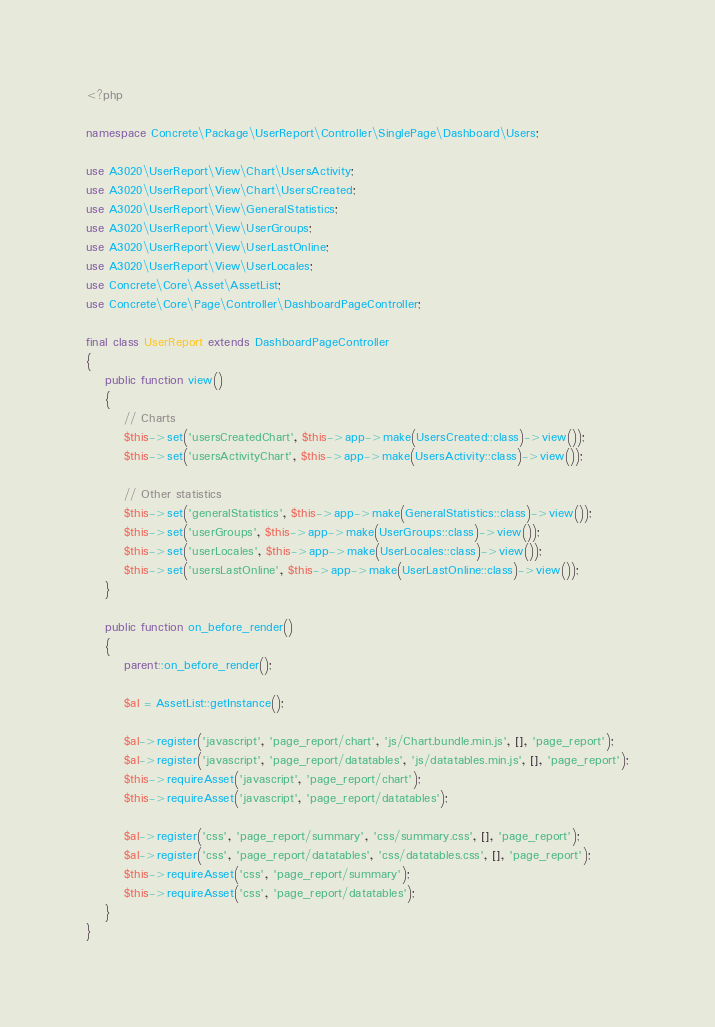Convert code to text. <code><loc_0><loc_0><loc_500><loc_500><_PHP_><?php

namespace Concrete\Package\UserReport\Controller\SinglePage\Dashboard\Users;

use A3020\UserReport\View\Chart\UsersActivity;
use A3020\UserReport\View\Chart\UsersCreated;
use A3020\UserReport\View\GeneralStatistics;
use A3020\UserReport\View\UserGroups;
use A3020\UserReport\View\UserLastOnline;
use A3020\UserReport\View\UserLocales;
use Concrete\Core\Asset\AssetList;
use Concrete\Core\Page\Controller\DashboardPageController;

final class UserReport extends DashboardPageController
{
    public function view()
    {
        // Charts
        $this->set('usersCreatedChart', $this->app->make(UsersCreated::class)->view());
        $this->set('usersActivityChart', $this->app->make(UsersActivity::class)->view());

        // Other statistics
        $this->set('generalStatistics', $this->app->make(GeneralStatistics::class)->view());
        $this->set('userGroups', $this->app->make(UserGroups::class)->view());
        $this->set('userLocales', $this->app->make(UserLocales::class)->view());
        $this->set('usersLastOnline', $this->app->make(UserLastOnline::class)->view());
    }

    public function on_before_render()
    {
        parent::on_before_render();

        $al = AssetList::getInstance();

        $al->register('javascript', 'page_report/chart', 'js/Chart.bundle.min.js', [], 'page_report');
        $al->register('javascript', 'page_report/datatables', 'js/datatables.min.js', [], 'page_report');
        $this->requireAsset('javascript', 'page_report/chart');
        $this->requireAsset('javascript', 'page_report/datatables');

        $al->register('css', 'page_report/summary', 'css/summary.css', [], 'page_report');
        $al->register('css', 'page_report/datatables', 'css/datatables.css', [], 'page_report');
        $this->requireAsset('css', 'page_report/summary');
        $this->requireAsset('css', 'page_report/datatables');
    }
}
</code> 